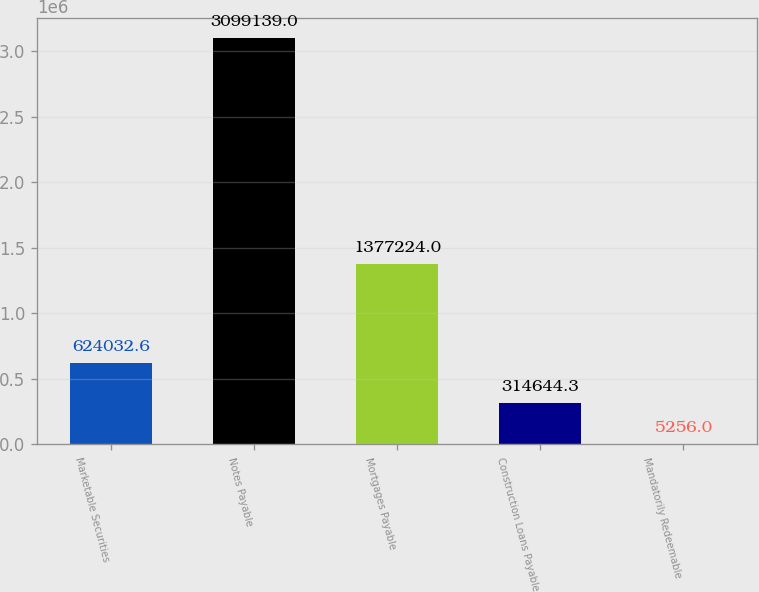Convert chart to OTSL. <chart><loc_0><loc_0><loc_500><loc_500><bar_chart><fcel>Marketable Securities<fcel>Notes Payable<fcel>Mortgages Payable<fcel>Construction Loans Payable<fcel>Mandatorily Redeemable<nl><fcel>624033<fcel>3.09914e+06<fcel>1.37722e+06<fcel>314644<fcel>5256<nl></chart> 